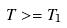Convert formula to latex. <formula><loc_0><loc_0><loc_500><loc_500>T > = T _ { 1 }</formula> 